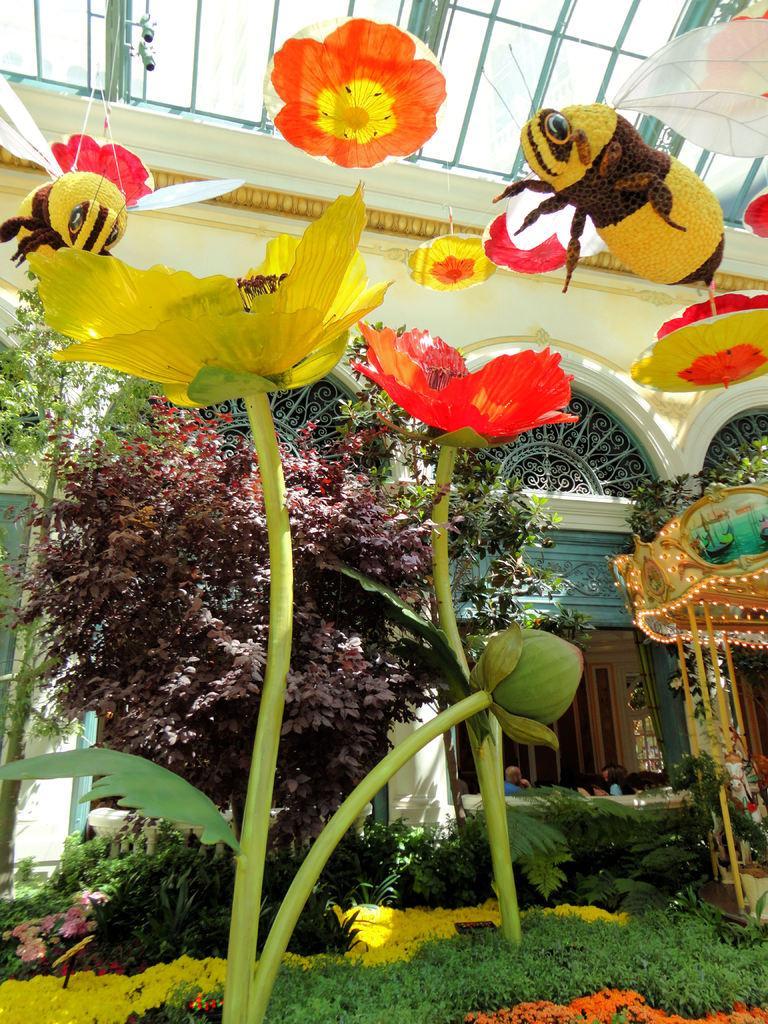Describe this image in one or two sentences. This image consists of trees in the middle. There is a building in the middle. There are some flowers in the middle. 